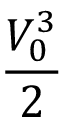<formula> <loc_0><loc_0><loc_500><loc_500>\frac { V _ { 0 } ^ { 3 } } { 2 }</formula> 